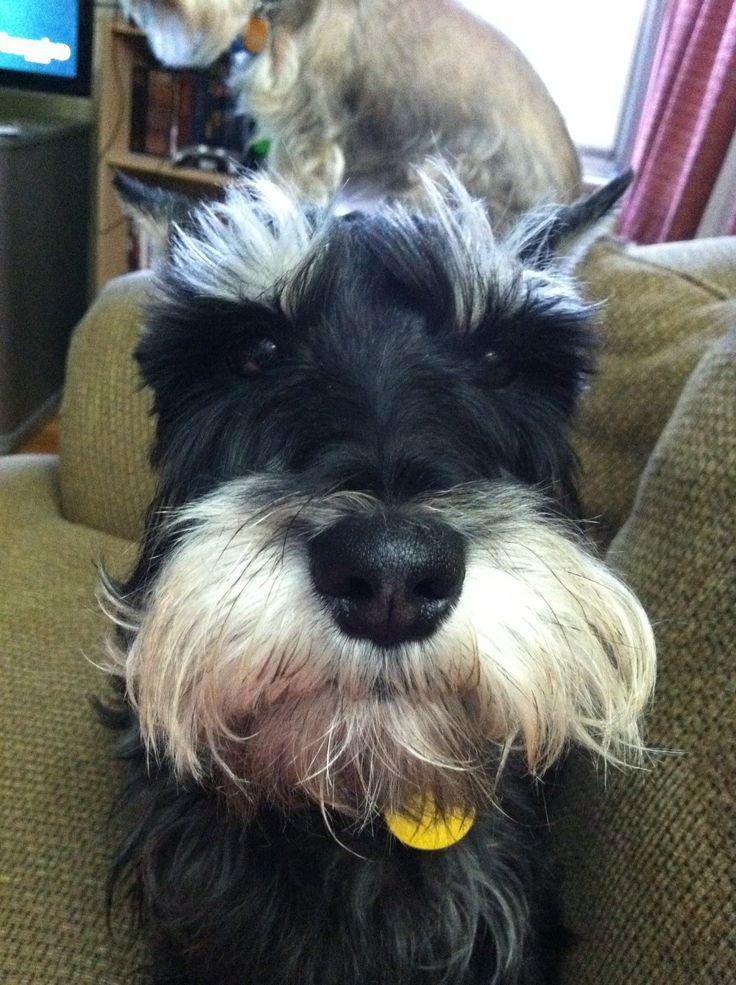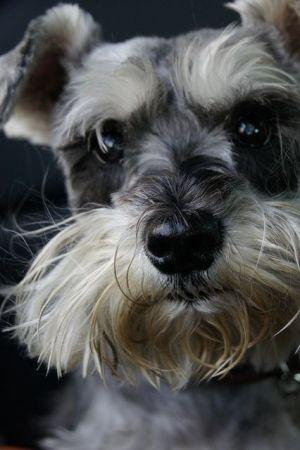The first image is the image on the left, the second image is the image on the right. Analyze the images presented: Is the assertion "One of the dogs is wearing a round tag on its collar." valid? Answer yes or no. Yes. The first image is the image on the left, the second image is the image on the right. Evaluate the accuracy of this statement regarding the images: "Each image shows a schnauzer with light-colored 'mustache and beard' fur, and each dog faces the camera with eyes visible.". Is it true? Answer yes or no. Yes. 